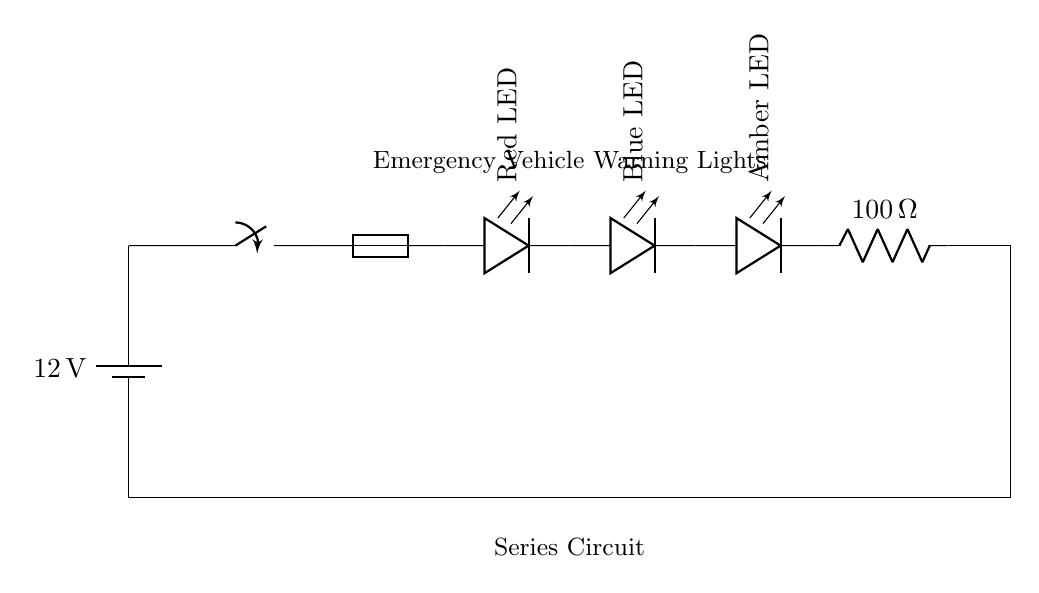What is the voltage of this circuit? The voltage source in the circuit is a battery labeled with 12V, which indicates the potential difference it provides to the entire circuit.
Answer: 12V What type of circuit is represented here? The diagram depicts a series circuit, evidenced by the single pathway connecting all components where the current flows through each element sequentially.
Answer: Series circuit How many LED lights are used in this circuit? The diagram shows three LED lights (Red, Blue, and Amber), indicating that the circuit includes three distinct lighting elements in series.
Answer: Three What is the resistance value shown in the circuit? The circuit includes a resistor labeled with a resistance of 100 Ohms, which is indicated adjacent to the symbol for the resistor in the circuit diagram.
Answer: 100 Ohm If one LED fails, what will happen to the circuit? In a series circuit, if one component (like an LED) fails, the entire circuit becomes open, and all components stop functioning because there is no alternative path for the current to flow.
Answer: The circuit stops working What component is used to protect this circuit from overload? The fuse depicted in the circuit is designed to protect against overloads; it will blow if the current exceeds a certain threshold, breaking the circuit and preventing damage.
Answer: Fuse What would be the total current flowing through the circuit if the LEDs and resistor are connected to the battery? To find the total current, we need the total voltage (12V) and total resistance (100 Ohms); using Ohm's law (I = V/R), the current can be calculated as 12V / 100 Ohms = 0.12 Amps.
Answer: 0.12 Amps 